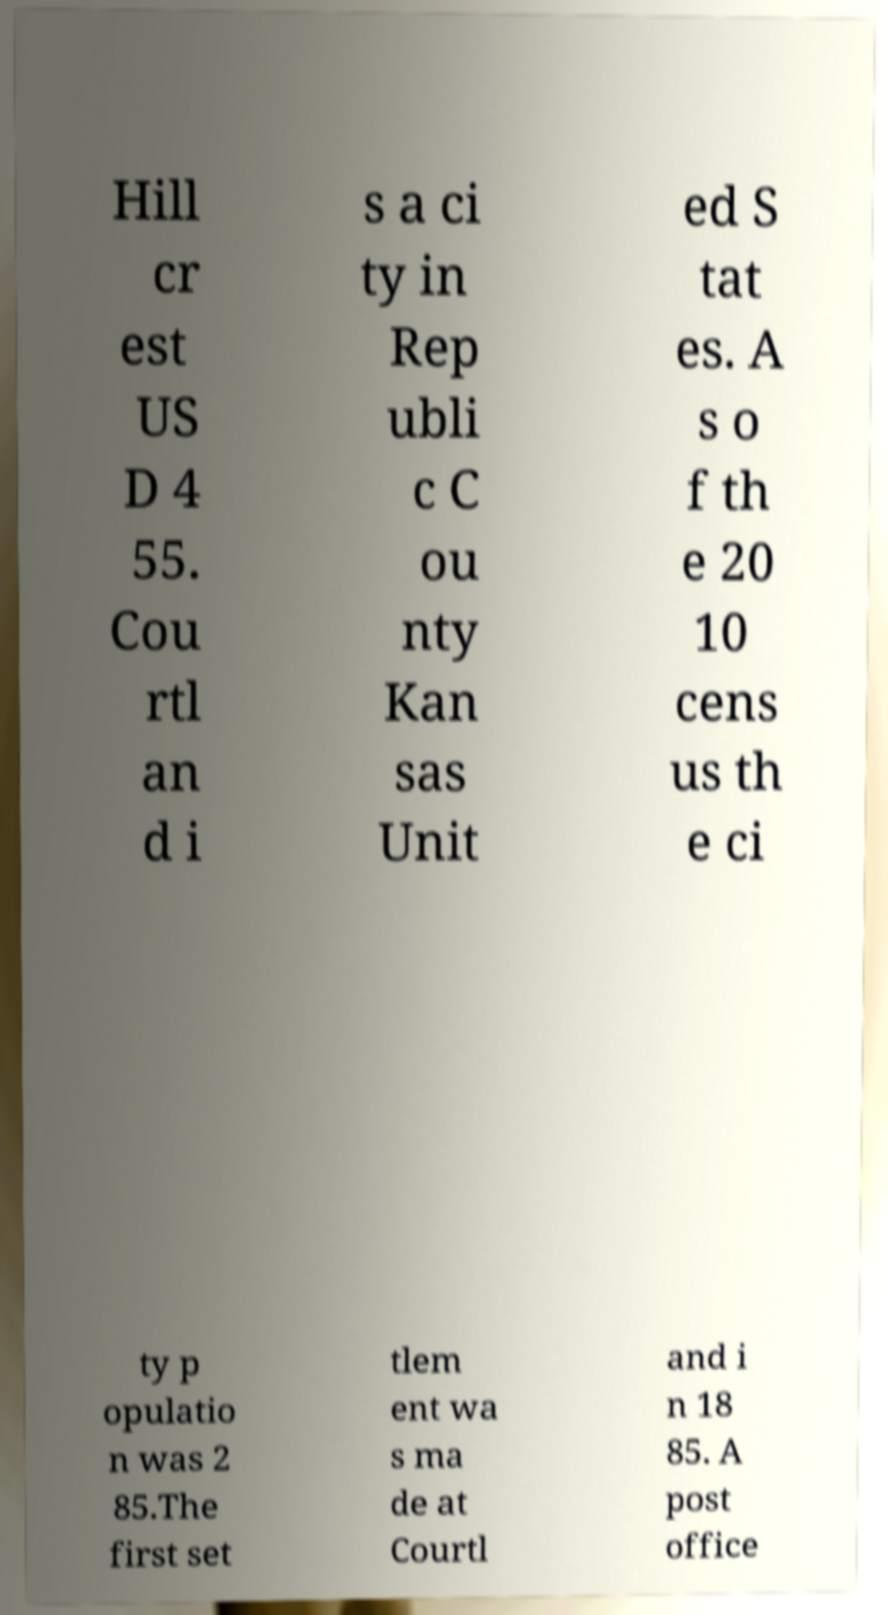For documentation purposes, I need the text within this image transcribed. Could you provide that? Hill cr est US D 4 55. Cou rtl an d i s a ci ty in Rep ubli c C ou nty Kan sas Unit ed S tat es. A s o f th e 20 10 cens us th e ci ty p opulatio n was 2 85.The first set tlem ent wa s ma de at Courtl and i n 18 85. A post office 